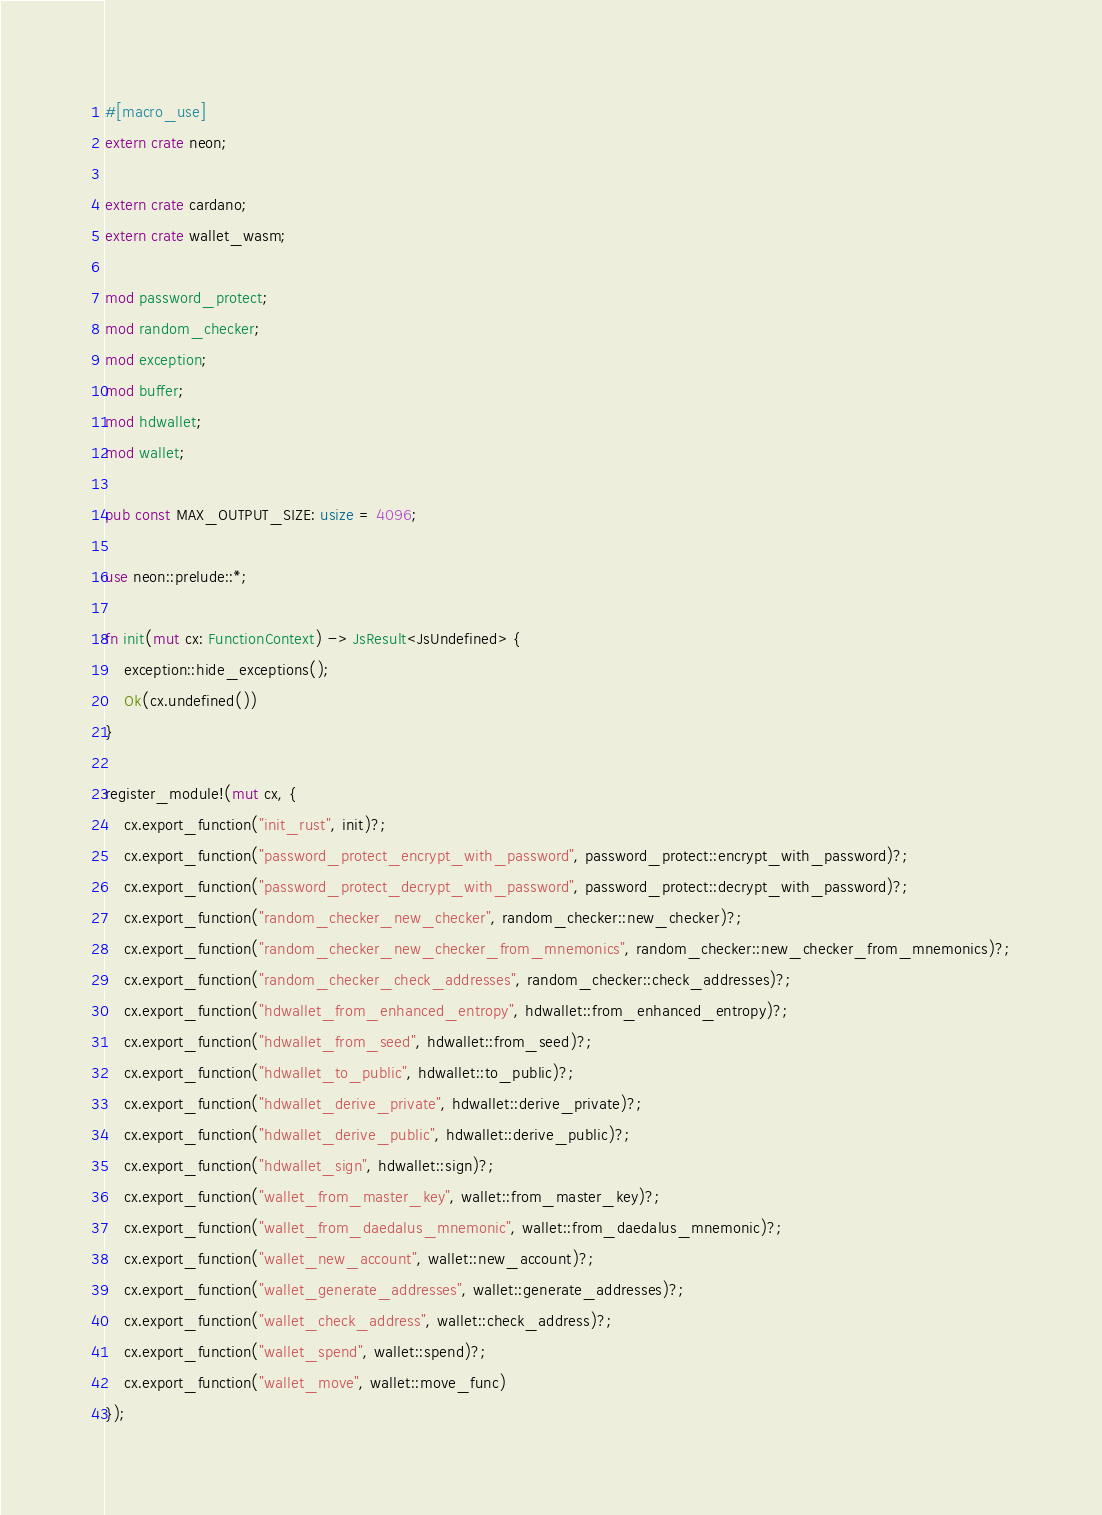Convert code to text. <code><loc_0><loc_0><loc_500><loc_500><_Rust_>#[macro_use]
extern crate neon;

extern crate cardano;
extern crate wallet_wasm;

mod password_protect;
mod random_checker;
mod exception;
mod buffer;
mod hdwallet;
mod wallet;

pub const MAX_OUTPUT_SIZE: usize = 4096;

use neon::prelude::*;

fn init(mut cx: FunctionContext) -> JsResult<JsUndefined> {
    exception::hide_exceptions();
    Ok(cx.undefined())
}

register_module!(mut cx, {
    cx.export_function("init_rust", init)?;
    cx.export_function("password_protect_encrypt_with_password", password_protect::encrypt_with_password)?;
    cx.export_function("password_protect_decrypt_with_password", password_protect::decrypt_with_password)?;
    cx.export_function("random_checker_new_checker", random_checker::new_checker)?;
    cx.export_function("random_checker_new_checker_from_mnemonics", random_checker::new_checker_from_mnemonics)?;
    cx.export_function("random_checker_check_addresses", random_checker::check_addresses)?;
    cx.export_function("hdwallet_from_enhanced_entropy", hdwallet::from_enhanced_entropy)?;
    cx.export_function("hdwallet_from_seed", hdwallet::from_seed)?;
    cx.export_function("hdwallet_to_public", hdwallet::to_public)?;
    cx.export_function("hdwallet_derive_private", hdwallet::derive_private)?;
    cx.export_function("hdwallet_derive_public", hdwallet::derive_public)?;
    cx.export_function("hdwallet_sign", hdwallet::sign)?;
    cx.export_function("wallet_from_master_key", wallet::from_master_key)?;
    cx.export_function("wallet_from_daedalus_mnemonic", wallet::from_daedalus_mnemonic)?;
    cx.export_function("wallet_new_account", wallet::new_account)?;
    cx.export_function("wallet_generate_addresses", wallet::generate_addresses)?;
    cx.export_function("wallet_check_address", wallet::check_address)?;
    cx.export_function("wallet_spend", wallet::spend)?;
    cx.export_function("wallet_move", wallet::move_func)
});
</code> 